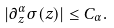<formula> <loc_0><loc_0><loc_500><loc_500>| \partial ^ { \alpha } _ { z } \sigma ( z ) | \leq C _ { \alpha } .</formula> 